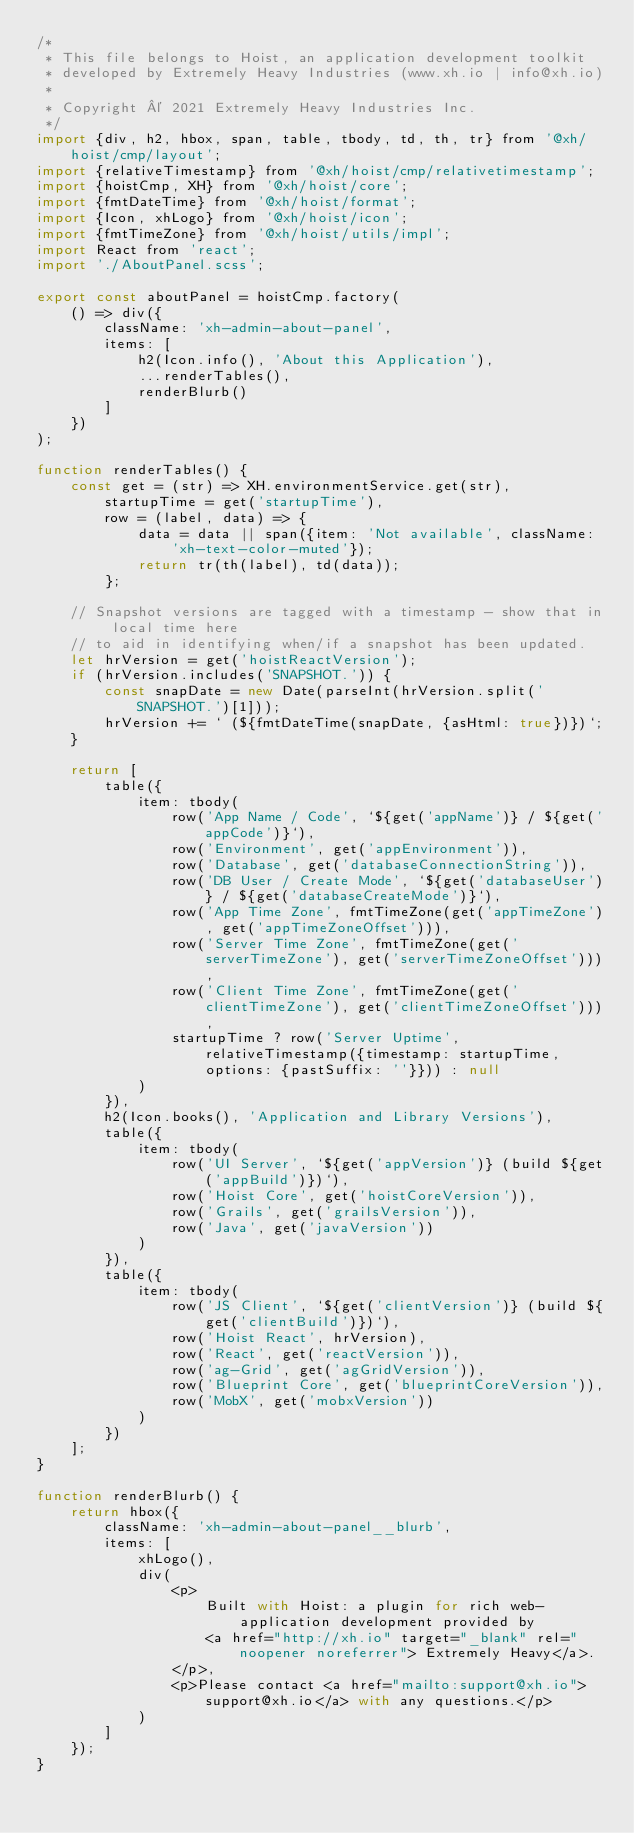<code> <loc_0><loc_0><loc_500><loc_500><_JavaScript_>/*
 * This file belongs to Hoist, an application development toolkit
 * developed by Extremely Heavy Industries (www.xh.io | info@xh.io)
 *
 * Copyright © 2021 Extremely Heavy Industries Inc.
 */
import {div, h2, hbox, span, table, tbody, td, th, tr} from '@xh/hoist/cmp/layout';
import {relativeTimestamp} from '@xh/hoist/cmp/relativetimestamp';
import {hoistCmp, XH} from '@xh/hoist/core';
import {fmtDateTime} from '@xh/hoist/format';
import {Icon, xhLogo} from '@xh/hoist/icon';
import {fmtTimeZone} from '@xh/hoist/utils/impl';
import React from 'react';
import './AboutPanel.scss';

export const aboutPanel = hoistCmp.factory(
    () => div({
        className: 'xh-admin-about-panel',
        items: [
            h2(Icon.info(), 'About this Application'),
            ...renderTables(),
            renderBlurb()
        ]
    })
);

function renderTables() {
    const get = (str) => XH.environmentService.get(str),
        startupTime = get('startupTime'),
        row = (label, data) => {
            data = data || span({item: 'Not available', className: 'xh-text-color-muted'});
            return tr(th(label), td(data));
        };

    // Snapshot versions are tagged with a timestamp - show that in local time here
    // to aid in identifying when/if a snapshot has been updated.
    let hrVersion = get('hoistReactVersion');
    if (hrVersion.includes('SNAPSHOT.')) {
        const snapDate = new Date(parseInt(hrVersion.split('SNAPSHOT.')[1]));
        hrVersion += ` (${fmtDateTime(snapDate, {asHtml: true})})`;
    }

    return [
        table({
            item: tbody(
                row('App Name / Code', `${get('appName')} / ${get('appCode')}`),
                row('Environment', get('appEnvironment')),
                row('Database', get('databaseConnectionString')),
                row('DB User / Create Mode', `${get('databaseUser')} / ${get('databaseCreateMode')}`),
                row('App Time Zone', fmtTimeZone(get('appTimeZone'), get('appTimeZoneOffset'))),
                row('Server Time Zone', fmtTimeZone(get('serverTimeZone'), get('serverTimeZoneOffset'))),
                row('Client Time Zone', fmtTimeZone(get('clientTimeZone'), get('clientTimeZoneOffset'))),
                startupTime ? row('Server Uptime', relativeTimestamp({timestamp: startupTime, options: {pastSuffix: ''}})) : null
            )
        }),
        h2(Icon.books(), 'Application and Library Versions'),
        table({
            item: tbody(
                row('UI Server', `${get('appVersion')} (build ${get('appBuild')})`),
                row('Hoist Core', get('hoistCoreVersion')),
                row('Grails', get('grailsVersion')),
                row('Java', get('javaVersion'))
            )
        }),
        table({
            item: tbody(
                row('JS Client', `${get('clientVersion')} (build ${get('clientBuild')})`),
                row('Hoist React', hrVersion),
                row('React', get('reactVersion')),
                row('ag-Grid', get('agGridVersion')),
                row('Blueprint Core', get('blueprintCoreVersion')),
                row('MobX', get('mobxVersion'))
            )
        })
    ];
}

function renderBlurb() {
    return hbox({
        className: 'xh-admin-about-panel__blurb',
        items: [
            xhLogo(),
            div(
                <p>
                    Built with Hoist: a plugin for rich web-application development provided by
                    <a href="http://xh.io" target="_blank" rel="noopener noreferrer"> Extremely Heavy</a>.
                </p>,
                <p>Please contact <a href="mailto:support@xh.io">support@xh.io</a> with any questions.</p>
            )
        ]
    });
}


</code> 